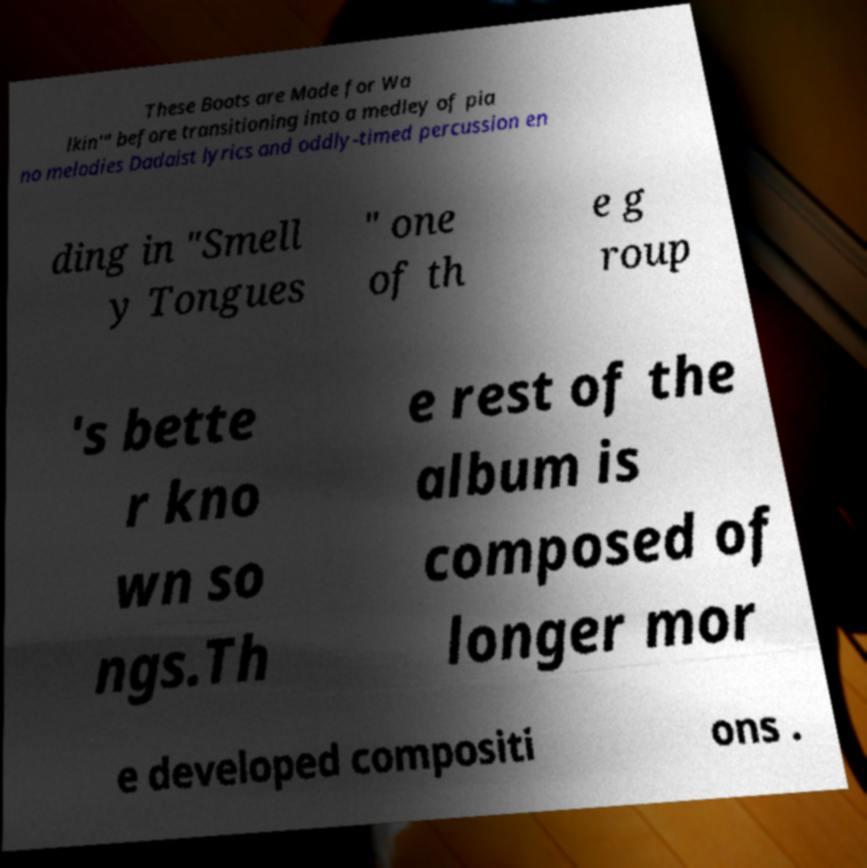Please read and relay the text visible in this image. What does it say? These Boots are Made for Wa lkin'" before transitioning into a medley of pia no melodies Dadaist lyrics and oddly-timed percussion en ding in "Smell y Tongues " one of th e g roup 's bette r kno wn so ngs.Th e rest of the album is composed of longer mor e developed compositi ons . 